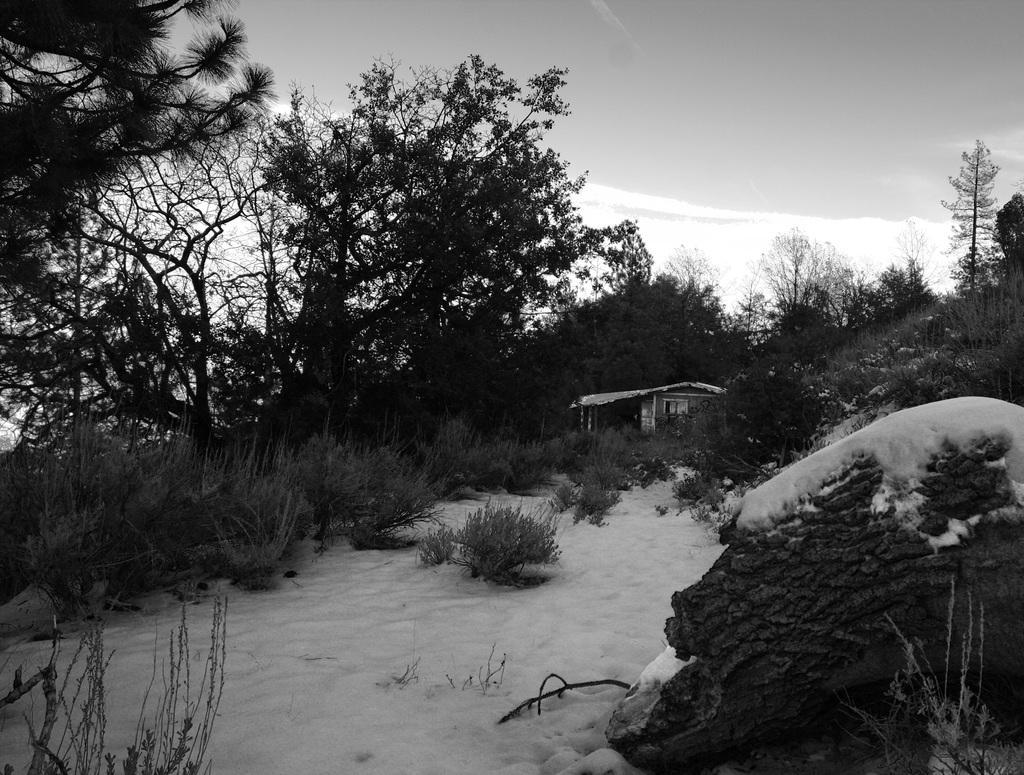How would you summarize this image in a sentence or two? In this picture we can see a house in the background, on the left side there are some trees and plants, on the right side there is a rock, it looks like snow at the bottom, there is the sky at the top of the picture, it is a black and white image. 